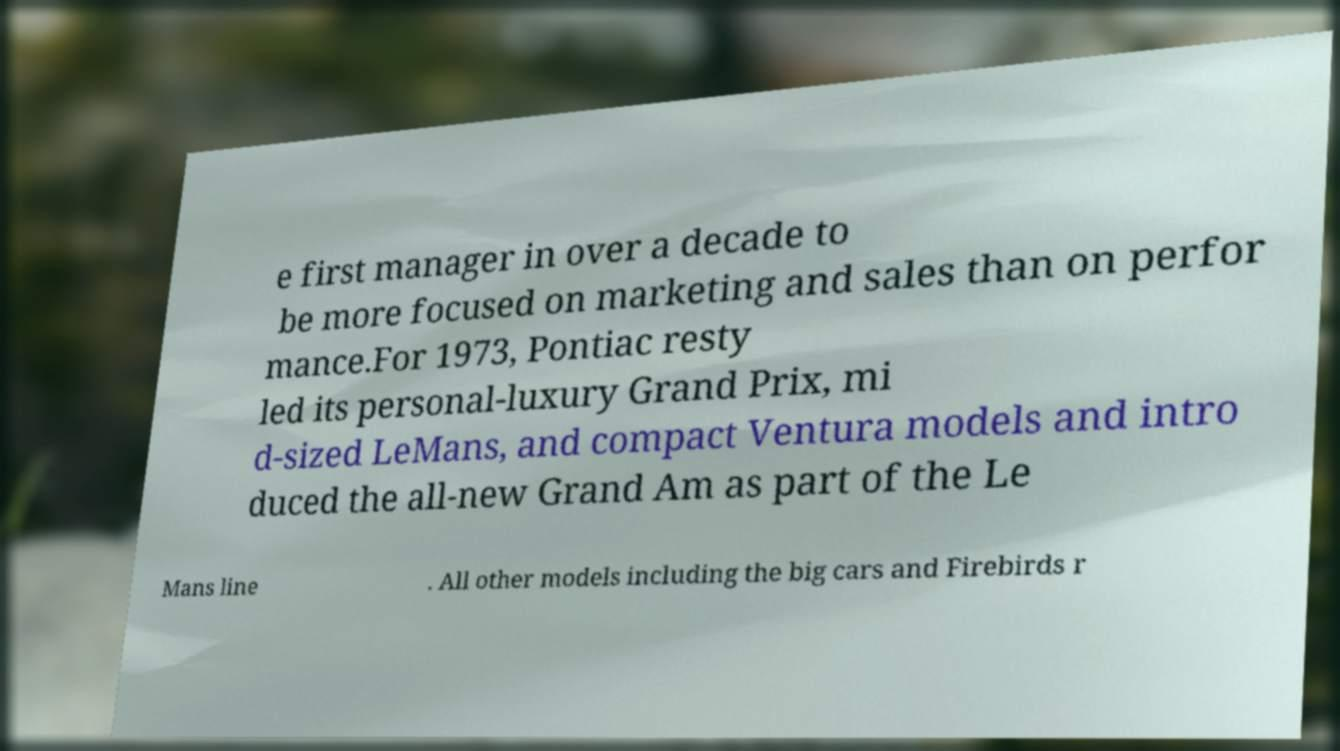Can you read and provide the text displayed in the image?This photo seems to have some interesting text. Can you extract and type it out for me? e first manager in over a decade to be more focused on marketing and sales than on perfor mance.For 1973, Pontiac resty led its personal-luxury Grand Prix, mi d-sized LeMans, and compact Ventura models and intro duced the all-new Grand Am as part of the Le Mans line . All other models including the big cars and Firebirds r 